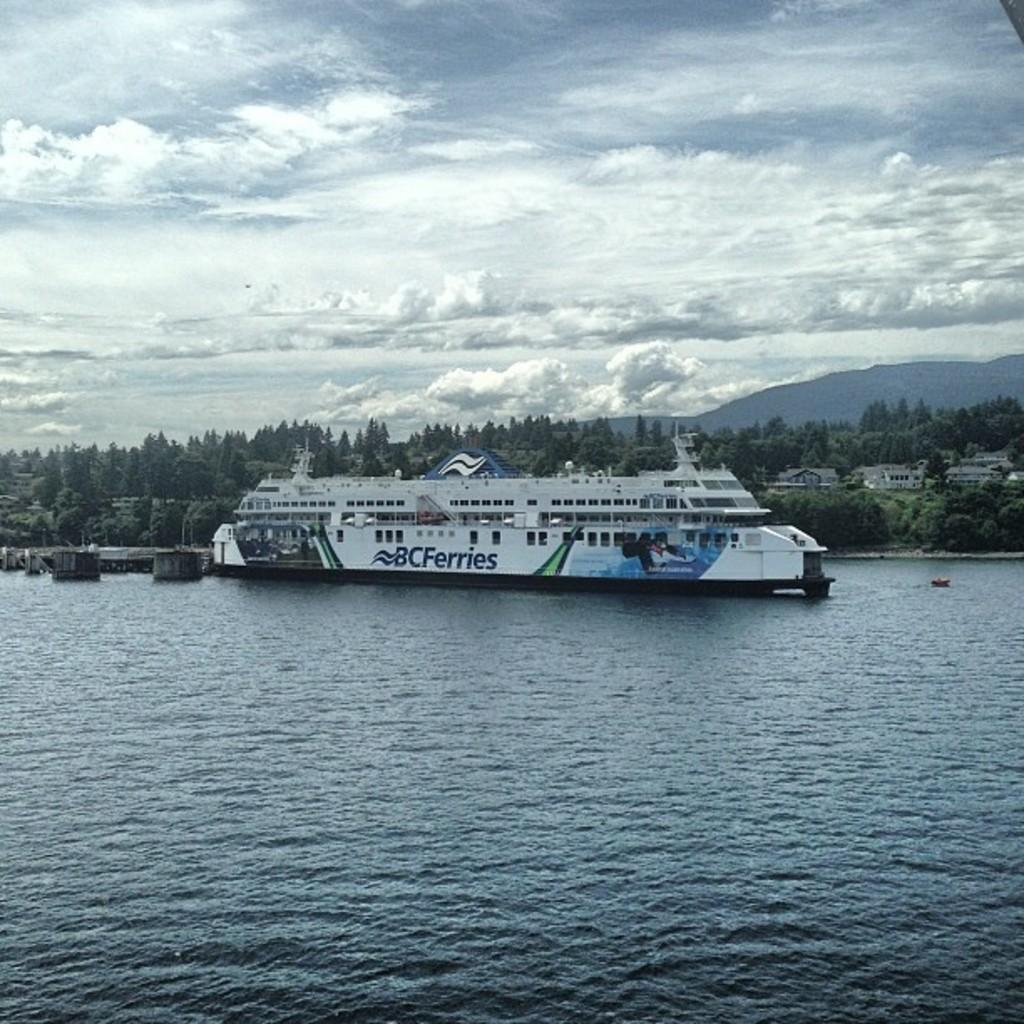What is the main subject of the image? The main subject of the image is a ship. Where is the ship located in the image? The ship is on the water. What features can be seen on the ship? The ship has windows and text or writing on it. What can be seen in the background of the image? In the background of the image, there are trees, buildings, hills, and the sky. What is the condition of the sky in the image? The sky is visible in the background of the image, and there are clouds present. How many women are singing in harmony on the ship in the image? There are no women or singing present in the image; it features a ship on the water with a background of trees, buildings, hills, and the sky. 